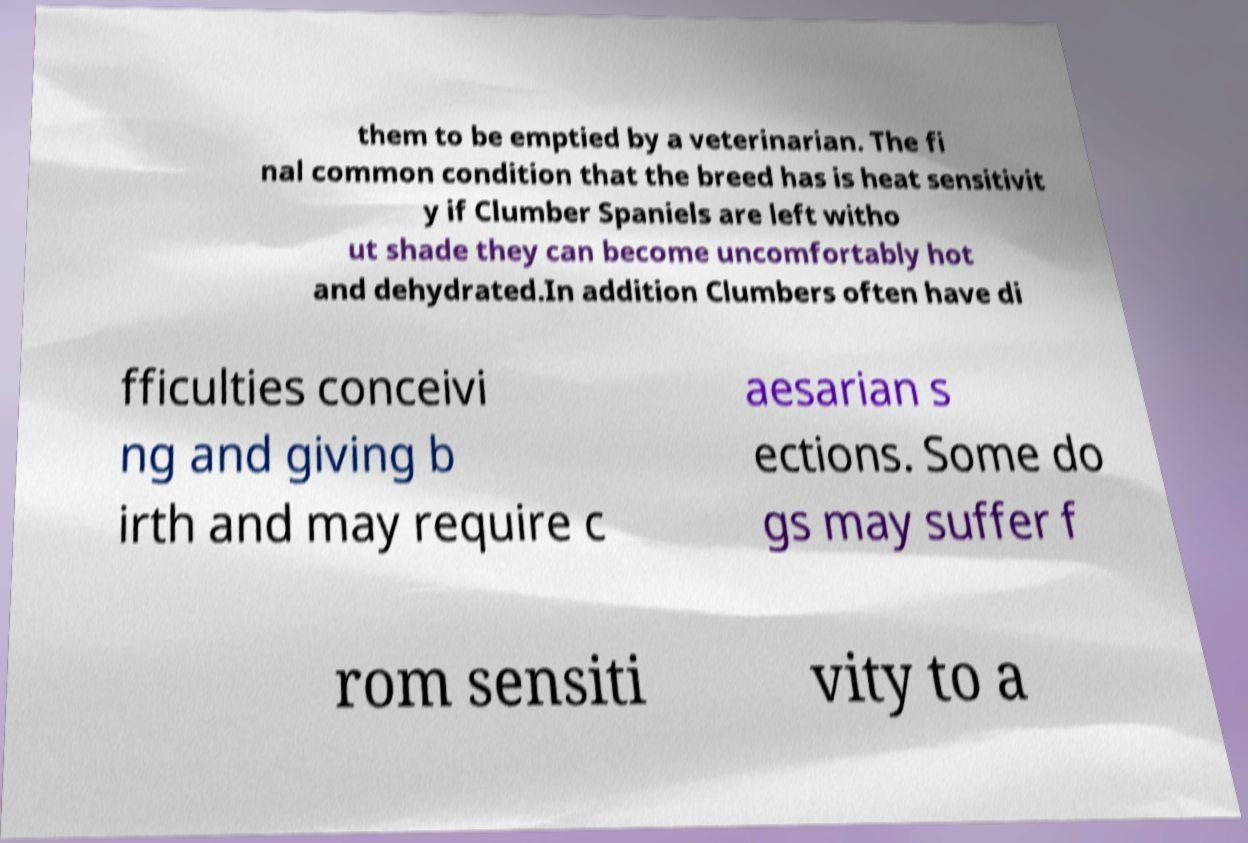For documentation purposes, I need the text within this image transcribed. Could you provide that? them to be emptied by a veterinarian. The fi nal common condition that the breed has is heat sensitivit y if Clumber Spaniels are left witho ut shade they can become uncomfortably hot and dehydrated.In addition Clumbers often have di fficulties conceivi ng and giving b irth and may require c aesarian s ections. Some do gs may suffer f rom sensiti vity to a 